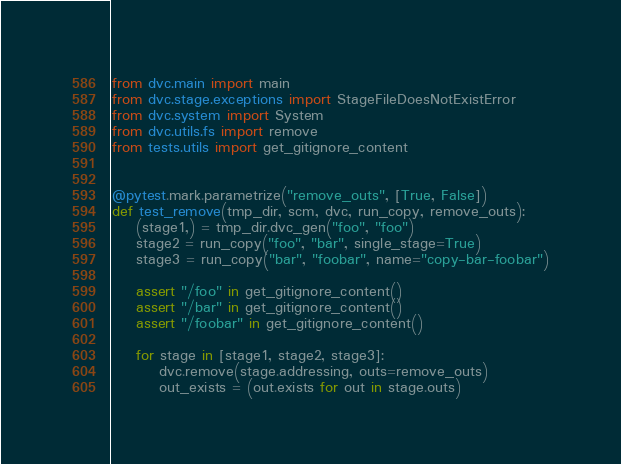Convert code to text. <code><loc_0><loc_0><loc_500><loc_500><_Python_>from dvc.main import main
from dvc.stage.exceptions import StageFileDoesNotExistError
from dvc.system import System
from dvc.utils.fs import remove
from tests.utils import get_gitignore_content


@pytest.mark.parametrize("remove_outs", [True, False])
def test_remove(tmp_dir, scm, dvc, run_copy, remove_outs):
    (stage1,) = tmp_dir.dvc_gen("foo", "foo")
    stage2 = run_copy("foo", "bar", single_stage=True)
    stage3 = run_copy("bar", "foobar", name="copy-bar-foobar")

    assert "/foo" in get_gitignore_content()
    assert "/bar" in get_gitignore_content()
    assert "/foobar" in get_gitignore_content()

    for stage in [stage1, stage2, stage3]:
        dvc.remove(stage.addressing, outs=remove_outs)
        out_exists = (out.exists for out in stage.outs)</code> 